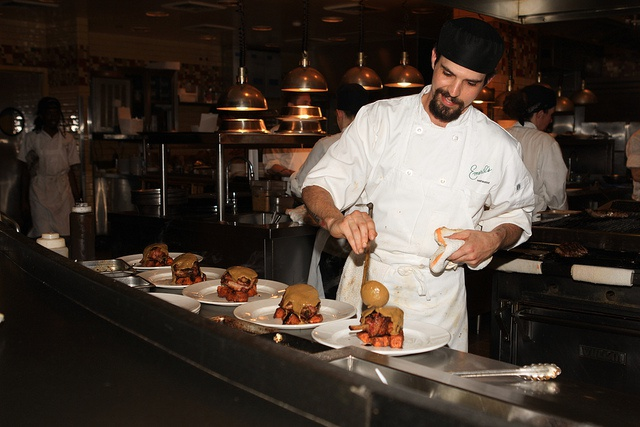Describe the objects in this image and their specific colors. I can see people in black, lightgray, brown, and darkgray tones, oven in black and gray tones, people in black, maroon, and brown tones, people in black, gray, and darkgray tones, and people in black, lightgray, and gray tones in this image. 